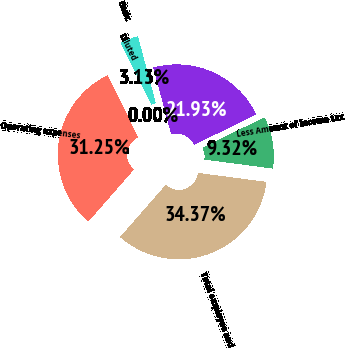Convert chart to OTSL. <chart><loc_0><loc_0><loc_500><loc_500><pie_chart><fcel>Operating expenses<fcel>Total employee and<fcel>Less Amount of income tax<fcel>Amount charged against net<fcel>Basic<fcel>Diluted<nl><fcel>31.25%<fcel>34.37%<fcel>9.32%<fcel>21.93%<fcel>3.13%<fcel>0.0%<nl></chart> 